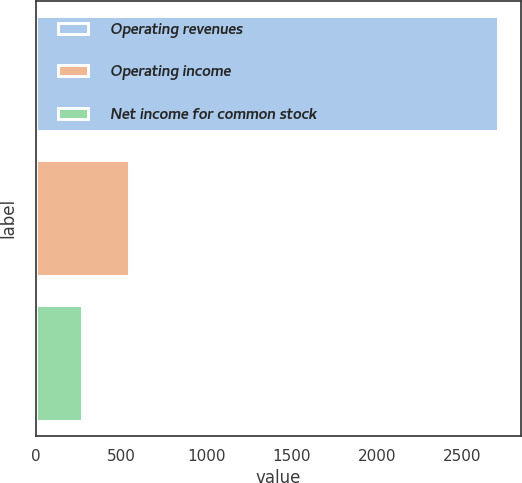<chart> <loc_0><loc_0><loc_500><loc_500><bar_chart><fcel>Operating revenues<fcel>Operating income<fcel>Net income for common stock<nl><fcel>2709<fcel>546<fcel>268<nl></chart> 